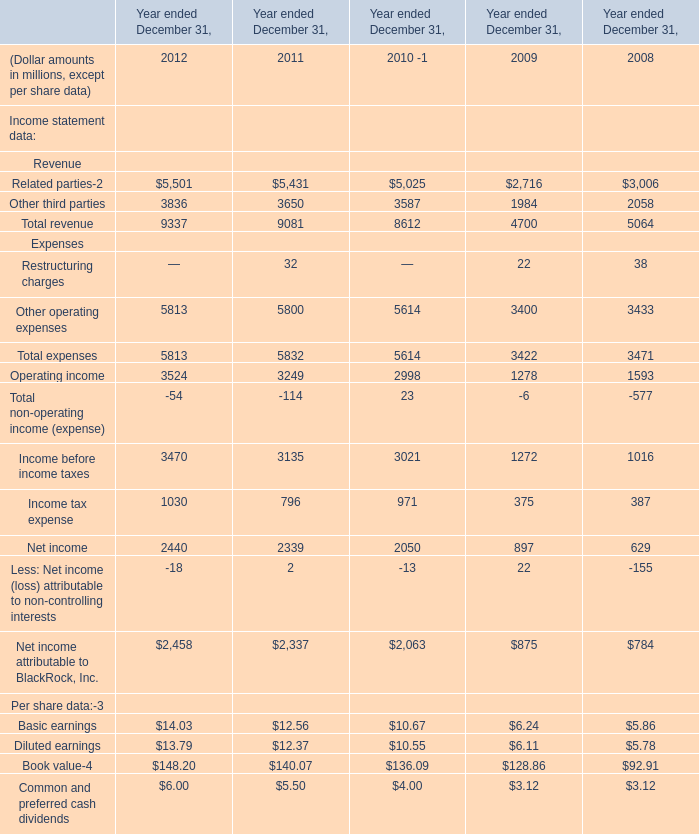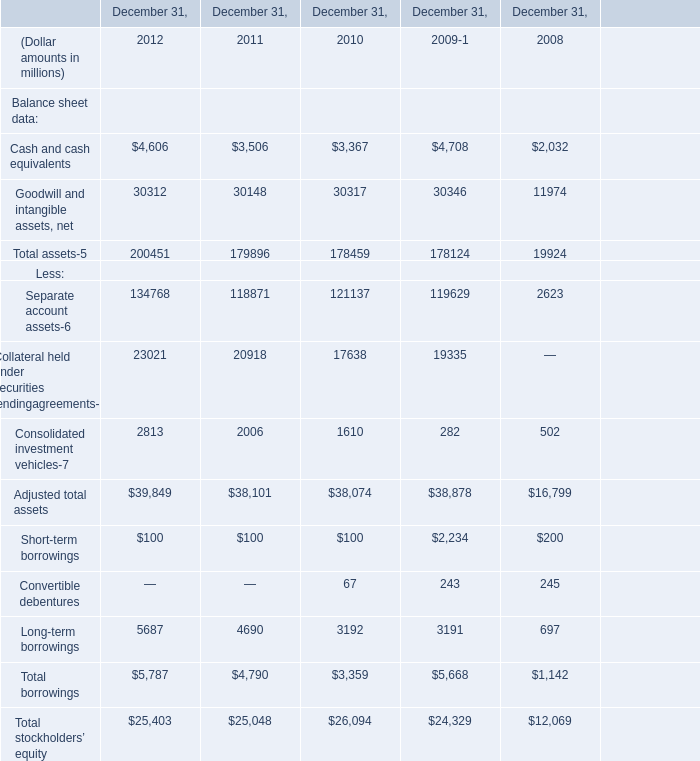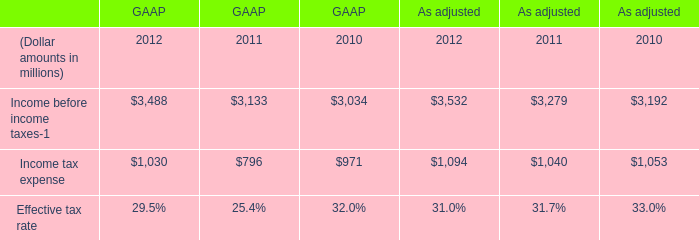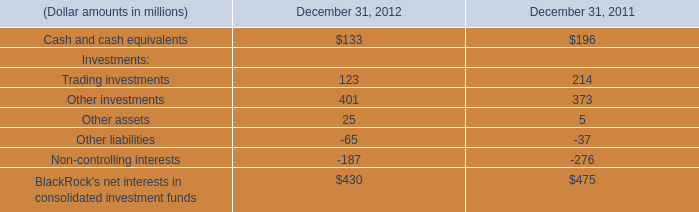If Cash and cash equivalents develops with the same increasing rate in 2012, what will it reach in 2013? (in million) 
Computations: (4606 * (1 + ((4606 - 3506) / 3506)))
Answer: 6051.12265. 